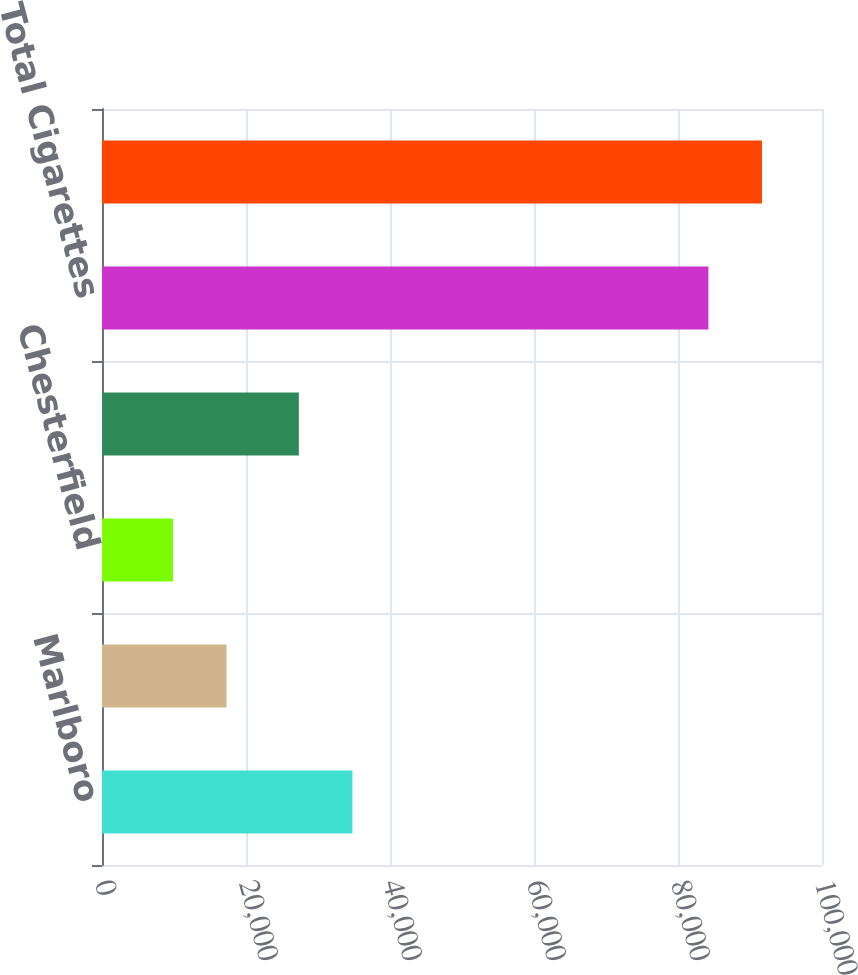Convert chart to OTSL. <chart><loc_0><loc_0><loc_500><loc_500><bar_chart><fcel>Marlboro<fcel>Philip Morris<fcel>Chesterfield<fcel>Others<fcel>Total Cigarettes<fcel>Total Latin America & Canada<nl><fcel>34779.8<fcel>17291.8<fcel>9852<fcel>27340<fcel>84223<fcel>91662.8<nl></chart> 